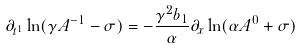<formula> <loc_0><loc_0><loc_500><loc_500>\partial _ { t ^ { 1 } } \ln ( \gamma A ^ { - 1 } - \sigma ) = - \frac { \gamma ^ { 2 } b _ { 1 } } { \alpha } \partial _ { x } \ln ( \alpha A ^ { 0 } + \sigma )</formula> 